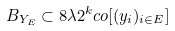Convert formula to latex. <formula><loc_0><loc_0><loc_500><loc_500>B _ { Y _ { E } } \subset 8 \lambda 2 ^ { k } c o [ ( y _ { i } ) _ { i \in E } ]</formula> 